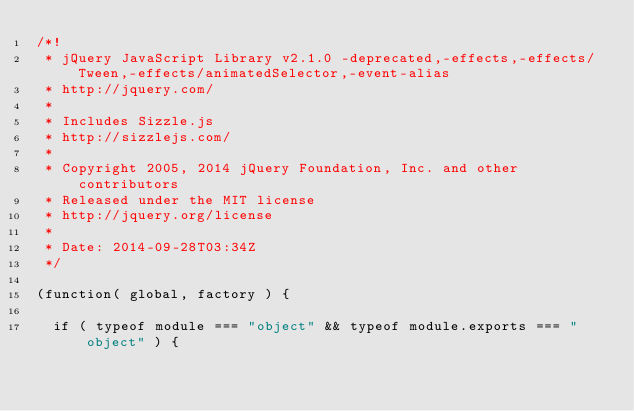<code> <loc_0><loc_0><loc_500><loc_500><_JavaScript_>/*!
 * jQuery JavaScript Library v2.1.0 -deprecated,-effects,-effects/Tween,-effects/animatedSelector,-event-alias
 * http://jquery.com/
 *
 * Includes Sizzle.js
 * http://sizzlejs.com/
 *
 * Copyright 2005, 2014 jQuery Foundation, Inc. and other contributors
 * Released under the MIT license
 * http://jquery.org/license
 *
 * Date: 2014-09-28T03:34Z
 */

(function( global, factory ) {

	if ( typeof module === "object" && typeof module.exports === "object" ) {</code> 